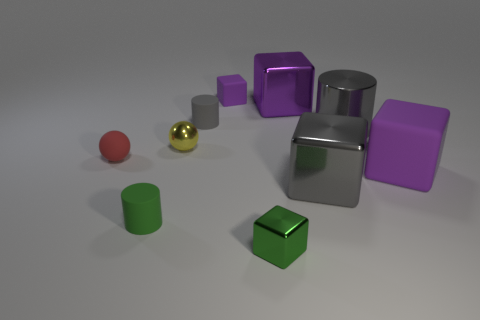There is a red thing that is the same shape as the yellow metallic object; what size is it?
Offer a very short reply. Small. Is there any other thing that has the same size as the gray metal cylinder?
Offer a very short reply. Yes. Do the small gray object and the small green shiny object have the same shape?
Give a very brief answer. No. What size is the matte cylinder that is behind the purple object in front of the small gray matte thing?
Provide a short and direct response. Small. The large metallic thing that is the same shape as the small green rubber thing is what color?
Your answer should be very brief. Gray. What number of large things are the same color as the large matte block?
Keep it short and to the point. 1. The metal cylinder has what size?
Ensure brevity in your answer.  Large. Is the purple metal block the same size as the yellow object?
Offer a very short reply. No. There is a rubber thing that is on the left side of the gray matte object and in front of the red sphere; what color is it?
Keep it short and to the point. Green. How many other gray cubes are the same material as the gray block?
Offer a terse response. 0. 